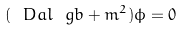Convert formula to latex. <formula><loc_0><loc_0><loc_500><loc_500>( \ D a l _ { \ } g b + m ^ { 2 } ) \phi = 0</formula> 